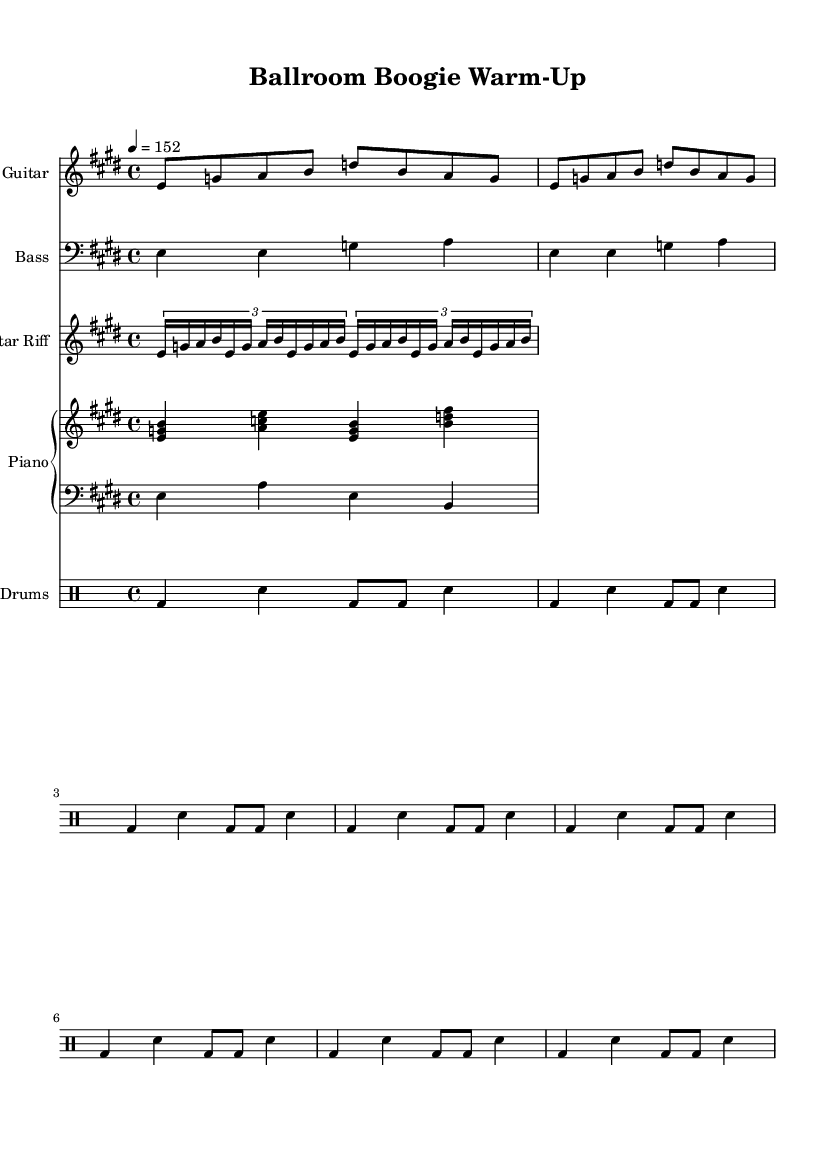What is the key signature of this music? The key signature is E major, which has four sharps: F sharp, C sharp, G sharp, and D sharp.
Answer: E major What is the time signature of this music? The time signature is 4/4, indicating there are four beats in each measure, and the quarter note receives one beat.
Answer: 4/4 What is the tempo marking for this piece? The tempo marking is 152, indicating it is a fast-paced piece set to 152 beats per minute.
Answer: 152 How many measures are repeated in the electric guitar part? The electric guitar part repeats 2 measures at the beginning and then continues. Thus, a total of 2 measures are repeated.
Answer: 2 measures Which instruments are included in this composition? The composition features Electric Guitar, Bass, Guitar Riff, Piano, and Drums. Therefore, all these instruments are included.
Answer: Electric Guitar, Bass, Guitar Riff, Piano, and Drums What type of rhythm is primarily used in the drums part? The rhythm in the drum part primarily consists of a combination of bass and snare hits, creating a typical driving rhythm found in electric blues.
Answer: Bass and snare hits 